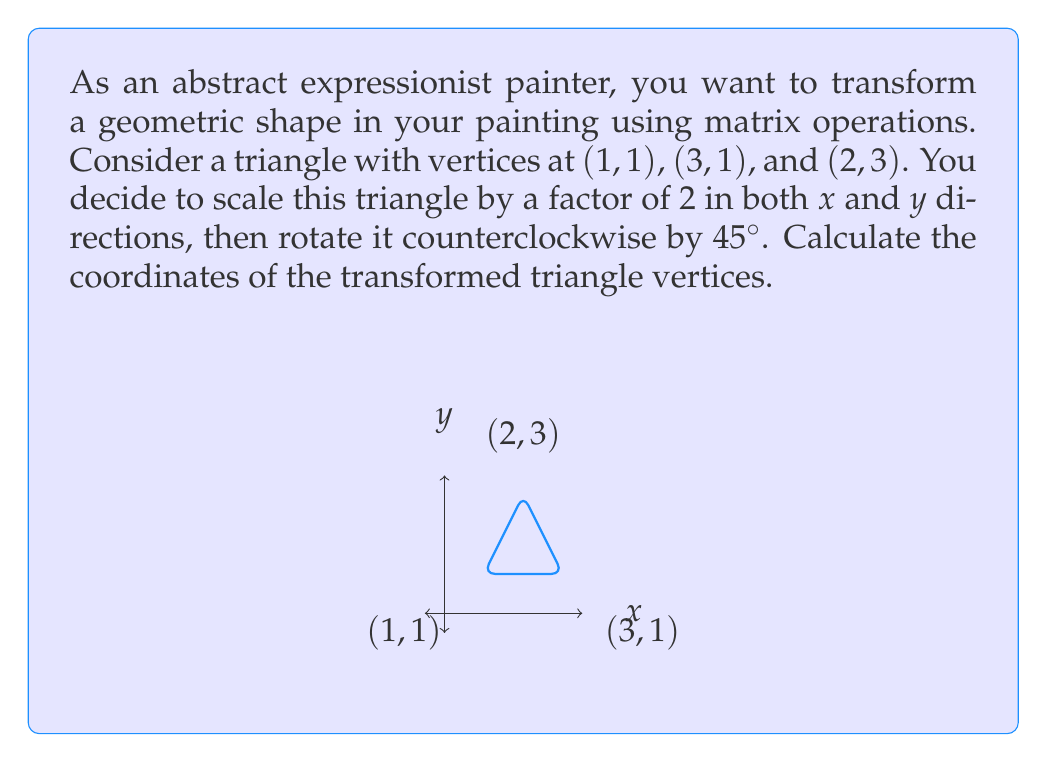What is the answer to this math problem? Let's approach this step-by-step:

1) First, we need to create our transformation matrices:

   Scaling matrix: $S = \begin{pmatrix} 2 & 0 \\ 0 & 2 \end{pmatrix}$
   
   Rotation matrix (45° = π/4 radians): 
   $R = \begin{pmatrix} \cos(\pi/4) & -\sin(\pi/4) \\ \sin(\pi/4) & \cos(\pi/4) \end{pmatrix} = \begin{pmatrix} \frac{\sqrt{2}}{2} & -\frac{\sqrt{2}}{2} \\ \frac{\sqrt{2}}{2} & \frac{\sqrt{2}}{2} \end{pmatrix}$

2) The combined transformation matrix is:

   $T = R \cdot S = \begin{pmatrix} \frac{\sqrt{2}}{2} & -\frac{\sqrt{2}}{2} \\ \frac{\sqrt{2}}{2} & \frac{\sqrt{2}}{2} \end{pmatrix} \cdot \begin{pmatrix} 2 & 0 \\ 0 & 2 \end{pmatrix} = \begin{pmatrix} \sqrt{2} & -\sqrt{2} \\ \sqrt{2} & \sqrt{2} \end{pmatrix}$

3) Now, we apply this transformation to each vertex:

   For (1, 1):
   $\begin{pmatrix} \sqrt{2} & -\sqrt{2} \\ \sqrt{2} & \sqrt{2} \end{pmatrix} \begin{pmatrix} 1 \\ 1 \end{pmatrix} = \begin{pmatrix} 0 \\ 2\sqrt{2} \end{pmatrix}$

   For (3, 1):
   $\begin{pmatrix} \sqrt{2} & -\sqrt{2} \\ \sqrt{2} & \sqrt{2} \end{pmatrix} \begin{pmatrix} 3 \\ 1 \end{pmatrix} = \begin{pmatrix} 2\sqrt{2} \\ 4\sqrt{2} \end{pmatrix}$

   For (2, 3):
   $\begin{pmatrix} \sqrt{2} & -\sqrt{2} \\ \sqrt{2} & \sqrt{2} \end{pmatrix} \begin{pmatrix} 2 \\ 3 \end{pmatrix} = \begin{pmatrix} -\sqrt{2} \\ 5\sqrt{2} \end{pmatrix}$

4) Therefore, the new coordinates of the triangle vertices are (0, 2√2), (2√2, 4√2), and (-√2, 5√2).
Answer: (0, 2√2), (2√2, 4√2), (-√2, 5√2) 